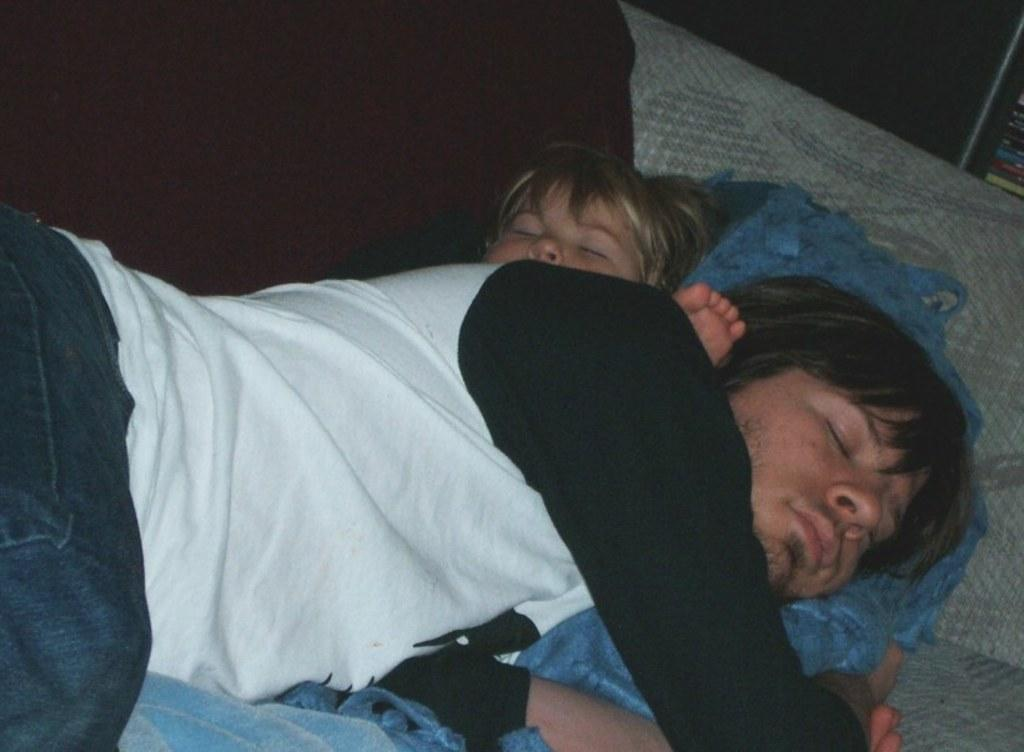How many people are in the image? There are two persons in the image. What are the persons doing in the image? The persons are sleeping on the bed. What is covering the persons on the bed? There are blankets on the bed. What type of vest can be seen hanging on the wall in the image? There is no vest present in the image; it only features two persons sleeping on a bed with blankets. 